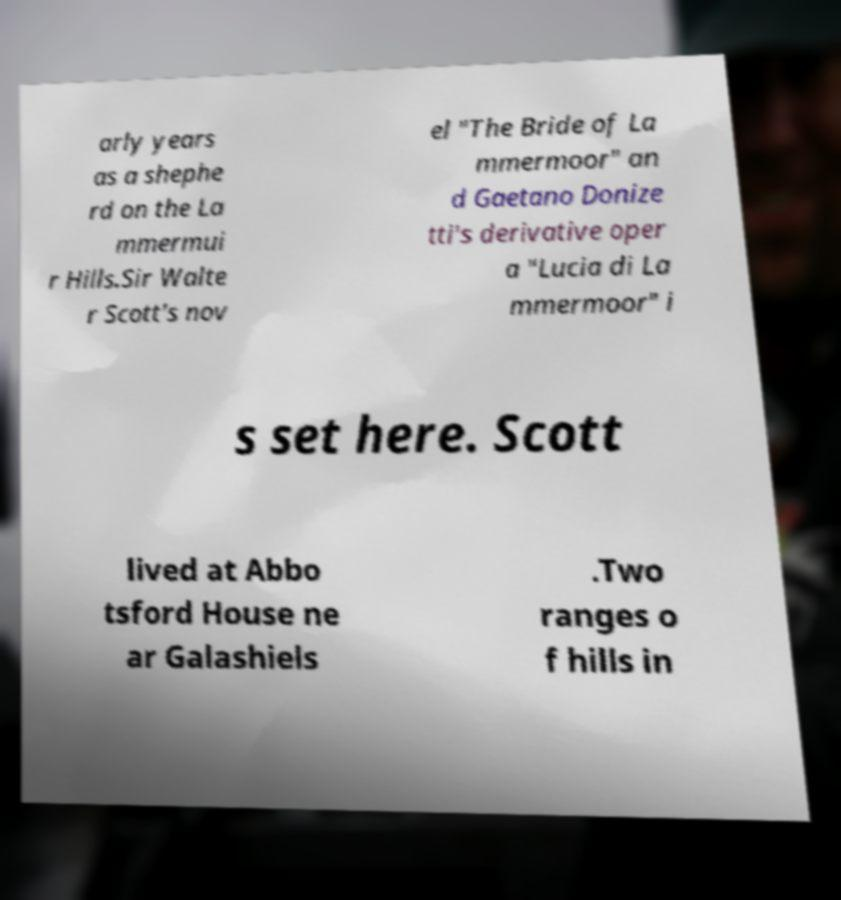Could you extract and type out the text from this image? arly years as a shephe rd on the La mmermui r Hills.Sir Walte r Scott's nov el "The Bride of La mmermoor" an d Gaetano Donize tti's derivative oper a "Lucia di La mmermoor" i s set here. Scott lived at Abbo tsford House ne ar Galashiels .Two ranges o f hills in 